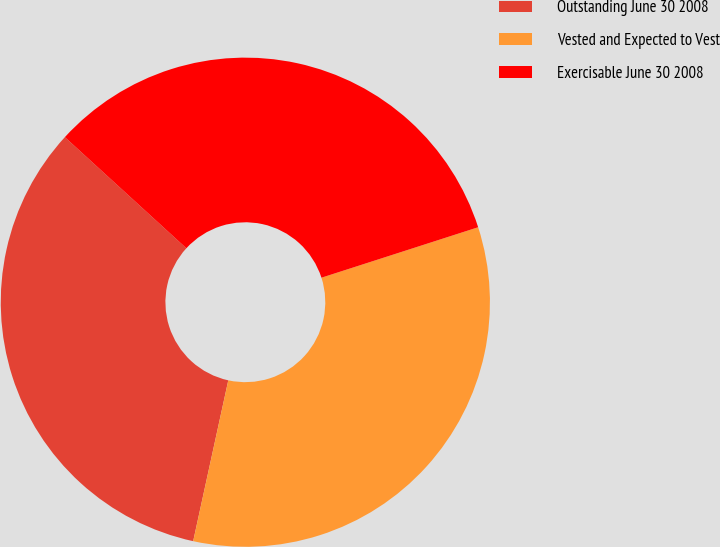Convert chart. <chart><loc_0><loc_0><loc_500><loc_500><pie_chart><fcel>Outstanding June 30 2008<fcel>Vested and Expected to Vest<fcel>Exercisable June 30 2008<nl><fcel>33.37%<fcel>33.38%<fcel>33.25%<nl></chart> 